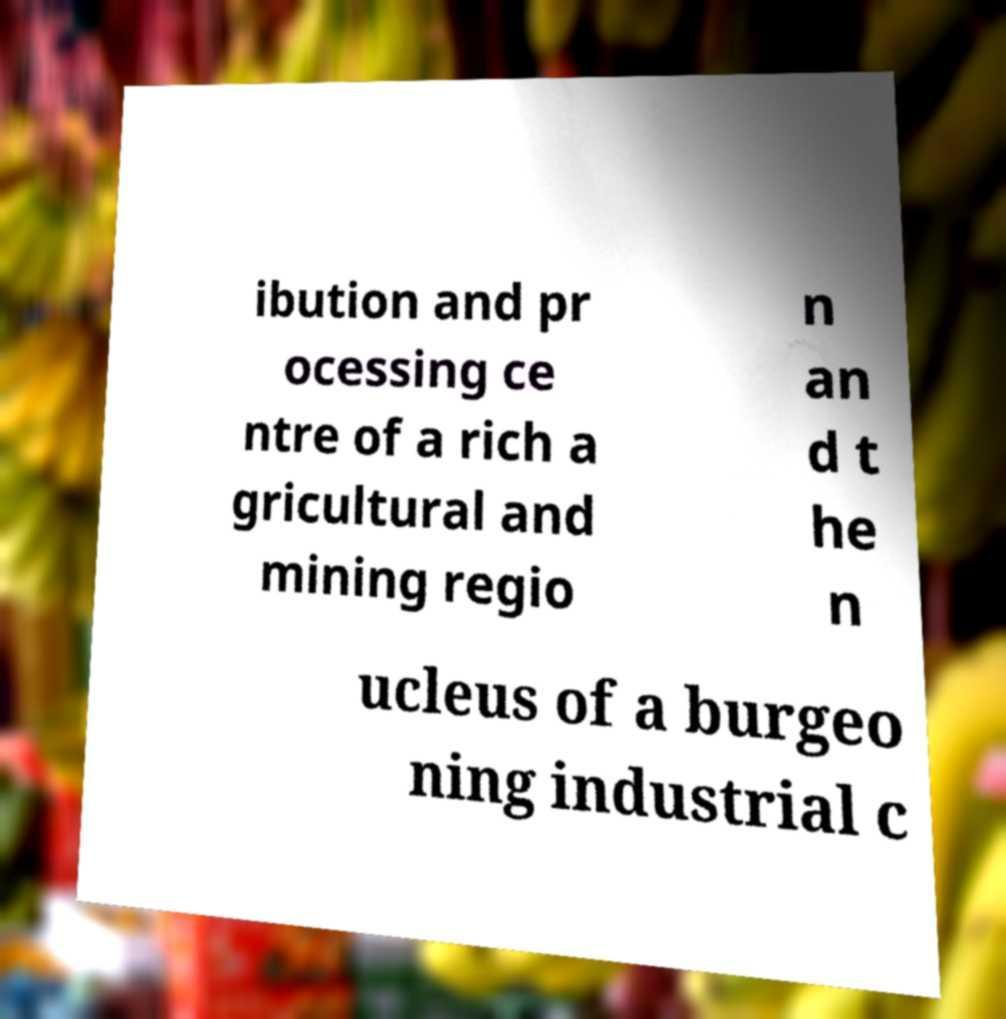What messages or text are displayed in this image? I need them in a readable, typed format. ibution and pr ocessing ce ntre of a rich a gricultural and mining regio n an d t he n ucleus of a burgeo ning industrial c 